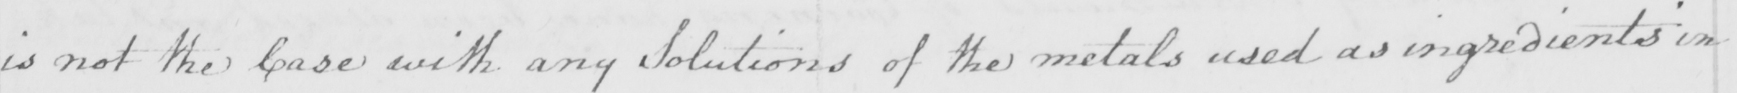Please transcribe the handwritten text in this image. is not the Case with any Solutions of the metals used as ingredients in 